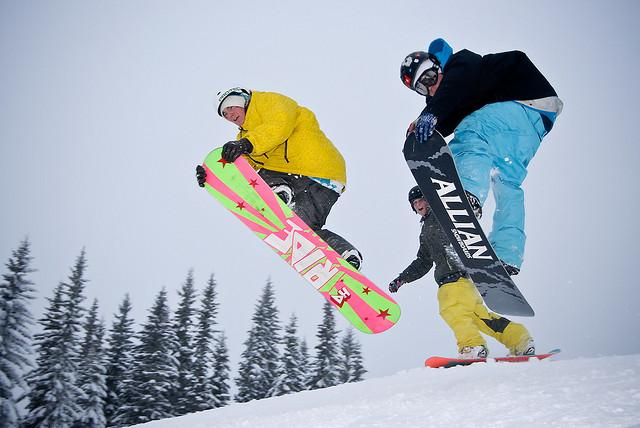What have these children likely practiced?

Choices:
A) boxing
B) sprinting
C) skiing
D) swimming skiing 